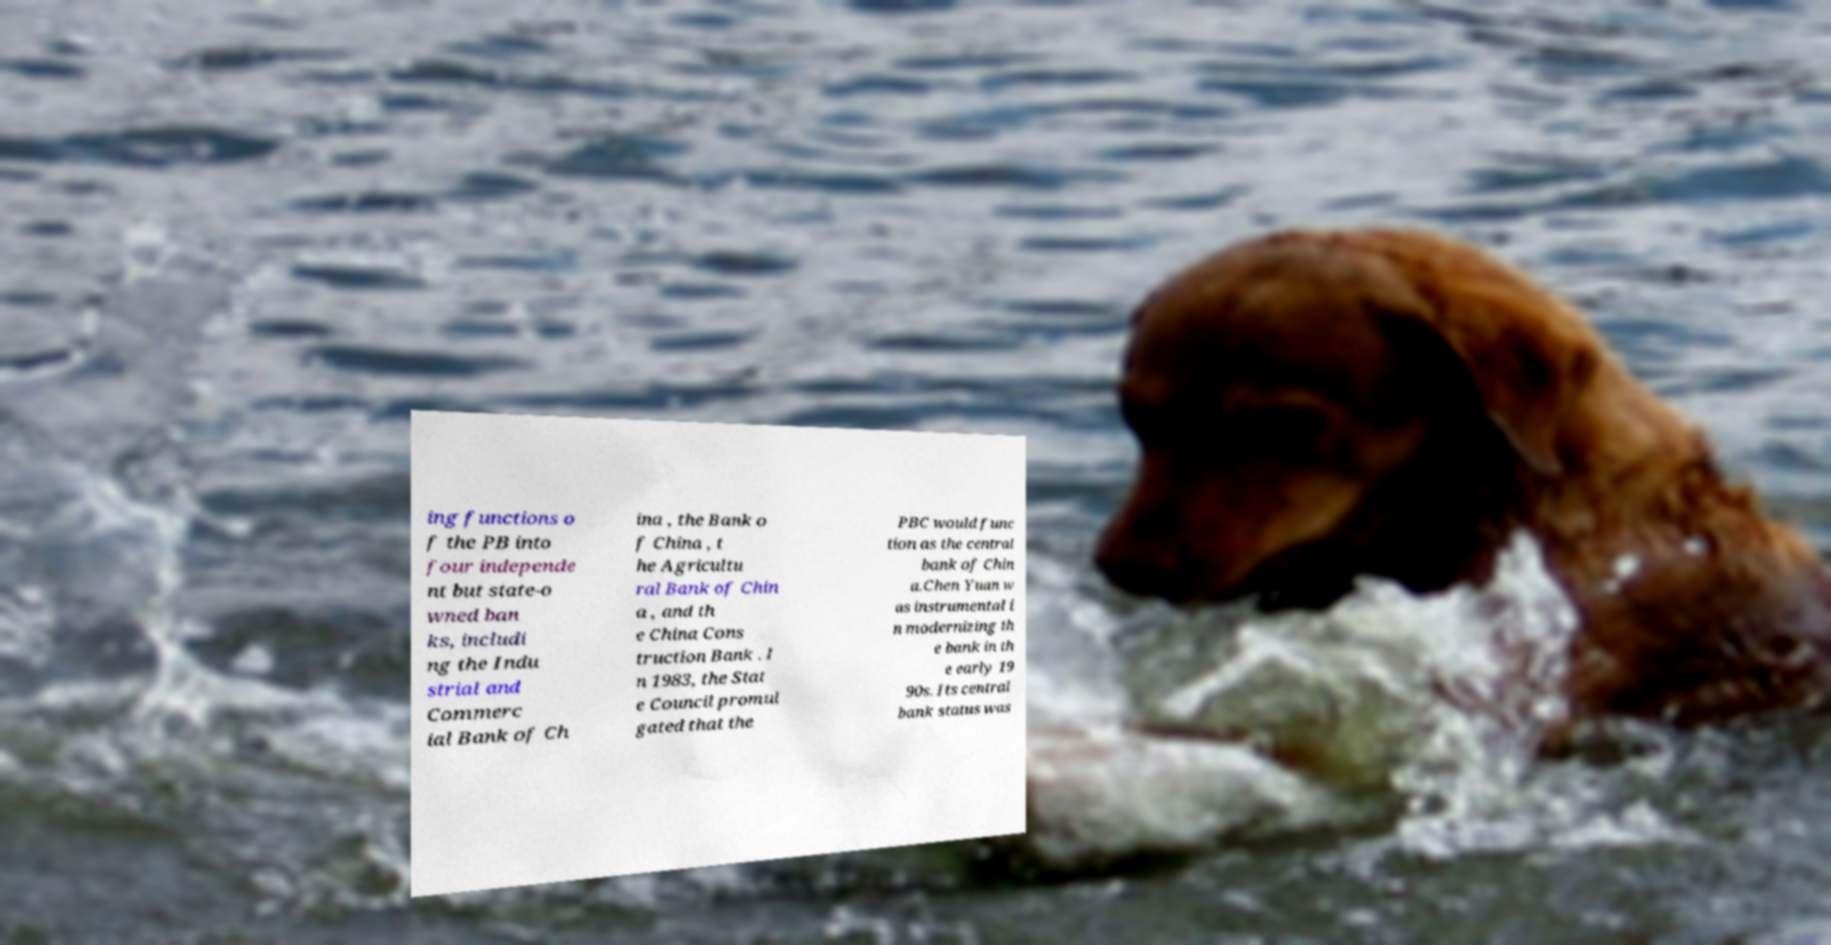I need the written content from this picture converted into text. Can you do that? ing functions o f the PB into four independe nt but state-o wned ban ks, includi ng the Indu strial and Commerc ial Bank of Ch ina , the Bank o f China , t he Agricultu ral Bank of Chin a , and th e China Cons truction Bank . I n 1983, the Stat e Council promul gated that the PBC would func tion as the central bank of Chin a.Chen Yuan w as instrumental i n modernizing th e bank in th e early 19 90s. Its central bank status was 